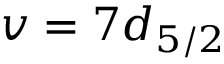Convert formula to latex. <formula><loc_0><loc_0><loc_500><loc_500>v = 7 d _ { 5 / 2 }</formula> 